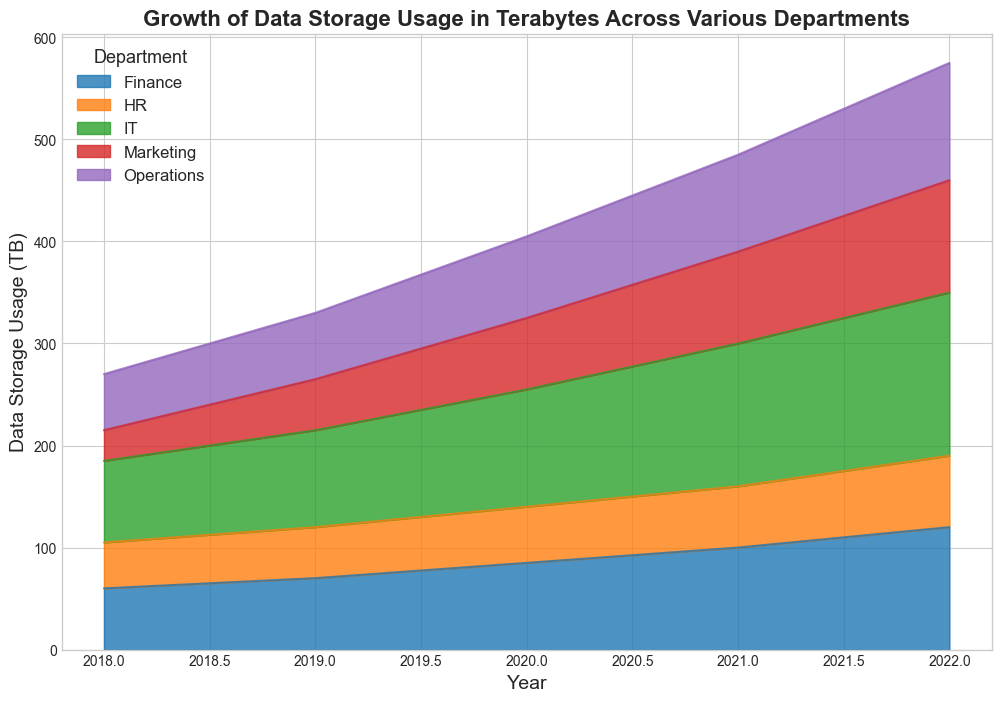What was the total data storage usage for all departments in 2020? To find the total data storage usage for all departments in 2020, sum up the values of each department for that year: HR (55 TB) + Finance (85 TB) + Marketing (70 TB) + IT (115 TB) + Operations (80 TB). The calculation is 55 + 85 + 70 + 115 + 80 = 405 TB.
Answer: 405 TB Which department experienced the highest growth in data storage usage from 2018 to 2022? To determine the department with the highest growth, calculate the difference in data storage usage from 2018 to 2022 for each department. HR: 70 - 45 = 25 TB, Finance: 120 - 60 = 60 TB, Marketing: 110 - 30 = 80 TB, IT: 160 - 80 = 80 TB, Operations: 115 - 55 = 60 TB. Both IT and Marketing experienced the highest growth of 80 TB.
Answer: IT and Marketing In 2021, which department used more data storage: Marketing or Operations? In 2021, the data storage usage for Marketing was 90 TB and for Operations was 95 TB. Therefore, Operations used more data storage in 2021.
Answer: Operations By observing the area sizes, in which year did Finance's data storage usage surpass HR's? By examining the area sizes corresponding to each department, it can be seen that Finance's data storage usage surpassed HR's before 2018 and remained higher throughout the given years.
Answer: Before 2018 What's the average yearly data storage usage for the IT department from 2018 to 2022? To find the average, sum up the IT department's data storage usage for all years and divide by the number of years: (80 + 95 + 115 + 140 + 160) TB / 5 = 590 TB / 5 = 118 TB.
Answer: 118 TB Which department saw a consistent yearly increase in data storage usage from 2018 to 2022? Checking each department, we see that HR increased from 45 to 70 TB, Finance from 60 to 120 TB, Marketing from 30 to 110 TB, IT from 80 to 160 TB, and Operations from 55 to 115 TB. All departments showed a consistent increase, but the question did not specify coinciding yearly amounts.
Answer: All departments Looking at the overall trend, did any department show a dip in data storage usage from one year to another? By observing the continuous and upward-facing areas, it's clear that no department showed a dip; each continually increased its data usage year over year.
Answer: No Compare the data storage usage of HR and Finance in 2019. Which department had a higher usage and by how much? In 2019, HR used 50 TB, and Finance used 70 TB. To find the difference: 70 TB - 50 TB = 20 TB. Finance had higher usage by 20 TB.
Answer: Finance by 20 TB 